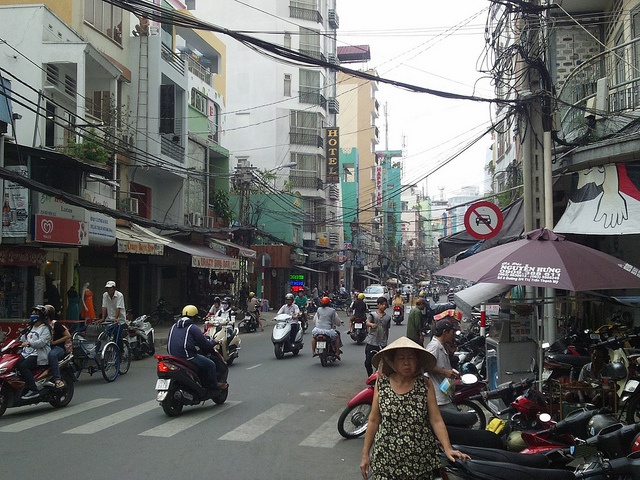Describe the objects in this image and their specific colors. I can see people in tan, black, and gray tones, umbrella in tan, gray, darkgray, black, and lightgray tones, motorcycle in tan, black, gray, maroon, and lightgray tones, people in tan, black, gray, darkgray, and lightgray tones, and motorcycle in tan, black, gray, and purple tones in this image. 